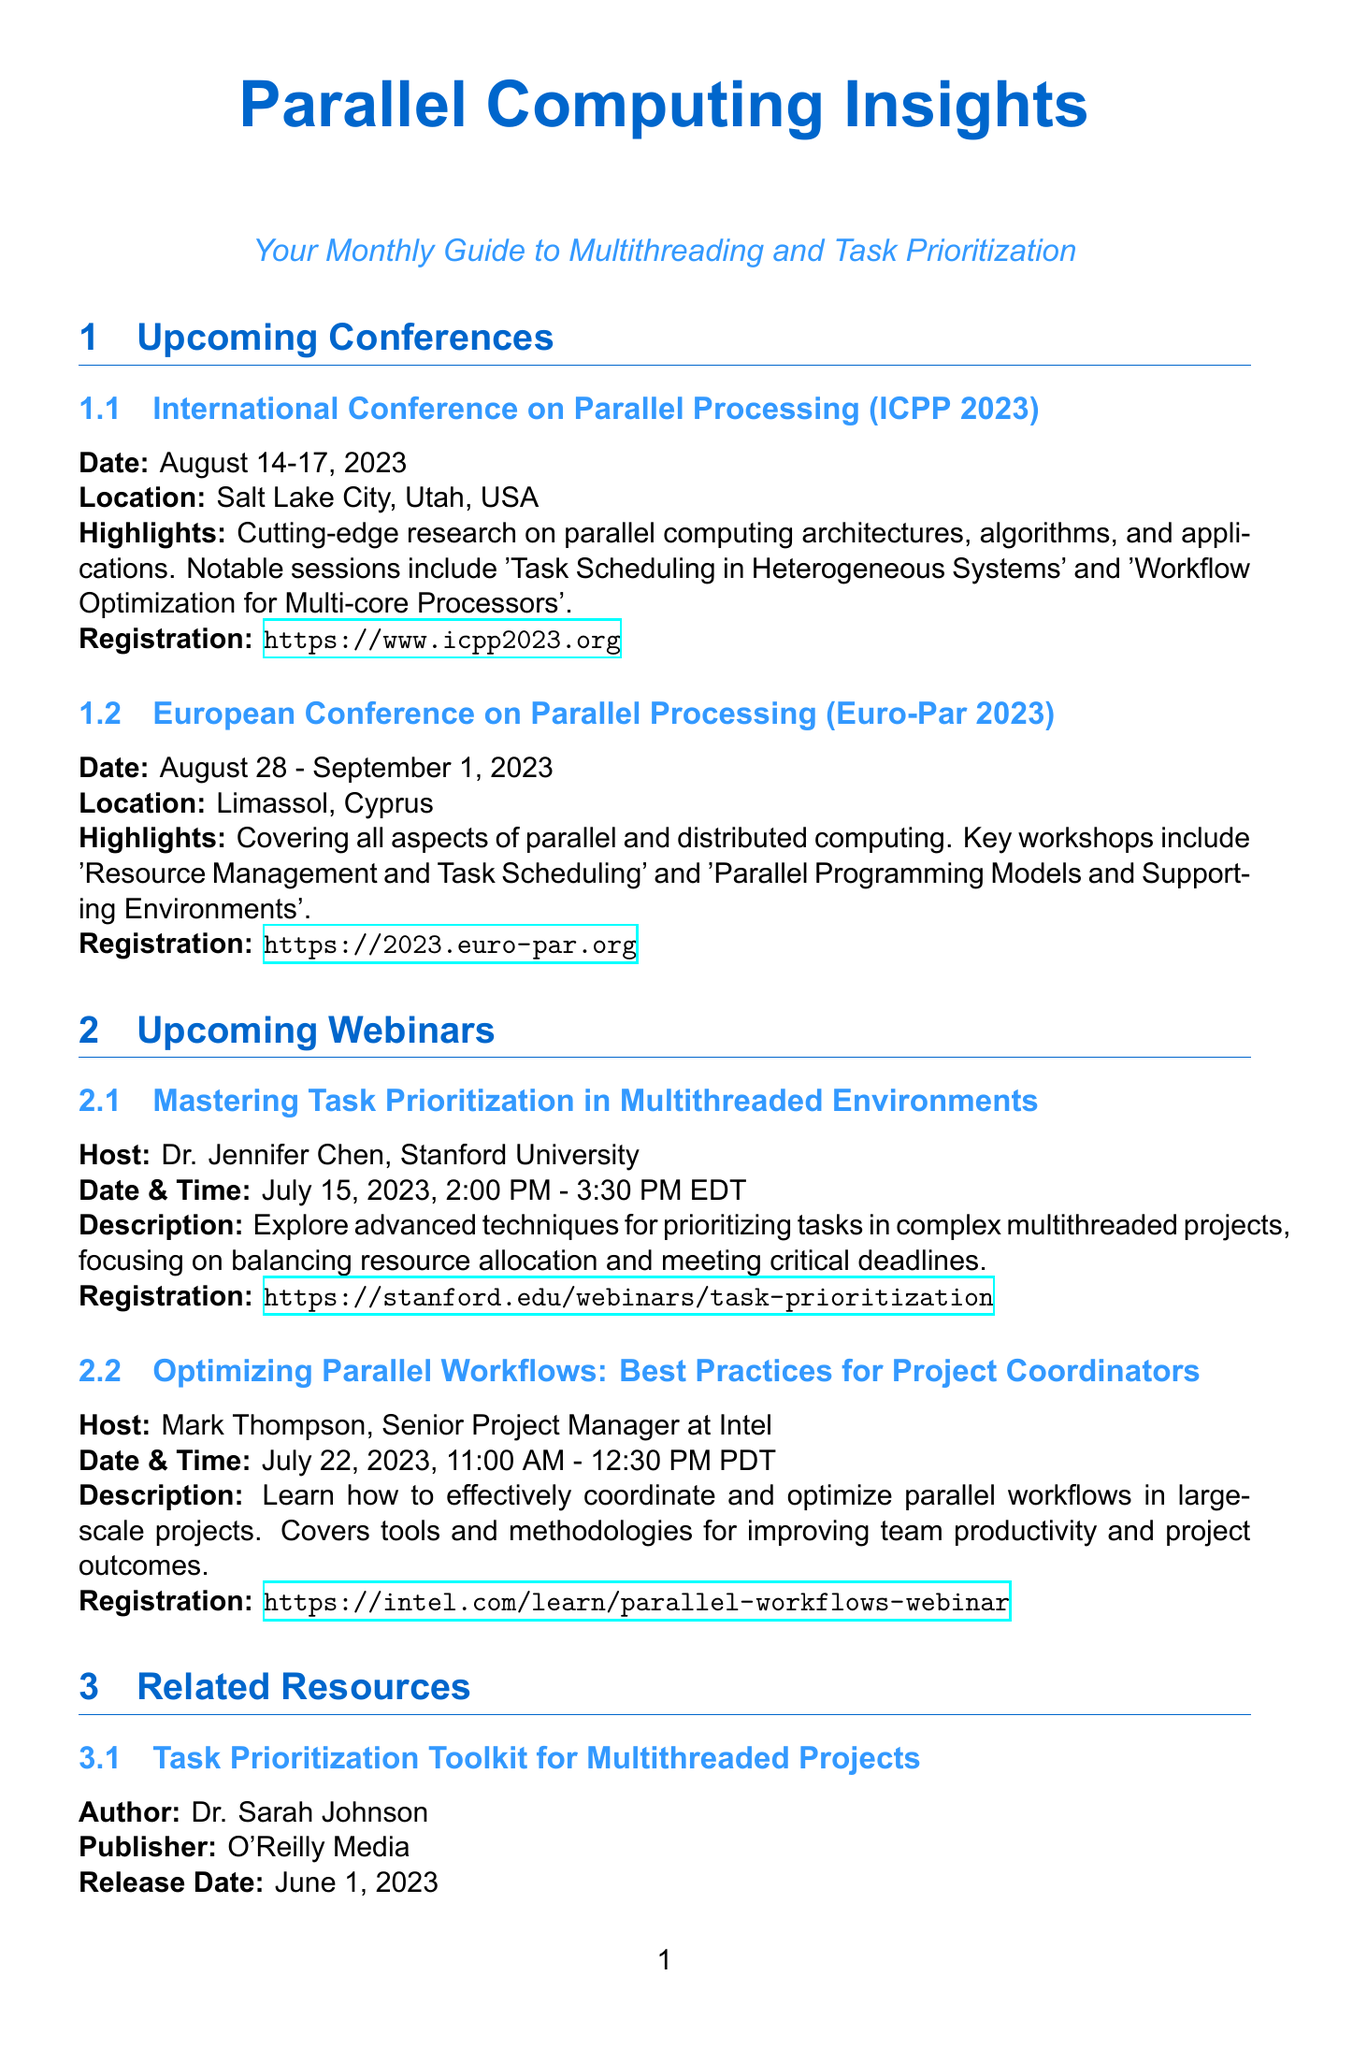What are the dates for ICPP 2023? The dates for ICPP 2023 are specifically listed in the document, which is August 14-17, 2023.
Answer: August 14-17, 2023 Where is Euro-Par 2023 being held? The location of Euro-Par 2023 is mentioned in the document as Limassol, Cyprus.
Answer: Limassol, Cyprus Who is hosting the webinar on task prioritization? The document specifies that Dr. Jennifer Chen from Stanford University is the host for this webinar.
Answer: Dr. Jennifer Chen What is the main focus of the webinar by Mark Thompson? The document highlights that the focus of Mark Thompson's webinar is on optimizing parallel workflows in large-scale projects.
Answer: Optimizing parallel workflows When was the Task Prioritization Toolkit published? The publication date for the Task Prioritization Toolkit is stated as June 1, 2023.
Answer: June 1, 2023 What type of content does the Parallel Computing Roadmap 2023 provide? The document describes that the Parallel Computing Roadmap 2023 offers insights on emerging technologies and their impact on task management.
Answer: Insights on emerging technologies Which organization published the Parallel Computing Roadmap 2023? The organization that published the report is specified in the document as IEEE Computer Society.
Answer: IEEE Computer Society What is the registration link for ICPP 2023? The document provides the registration link for ICPP 2023, which is https://www.icpp2023.org.
Answer: https://www.icpp2023.org 